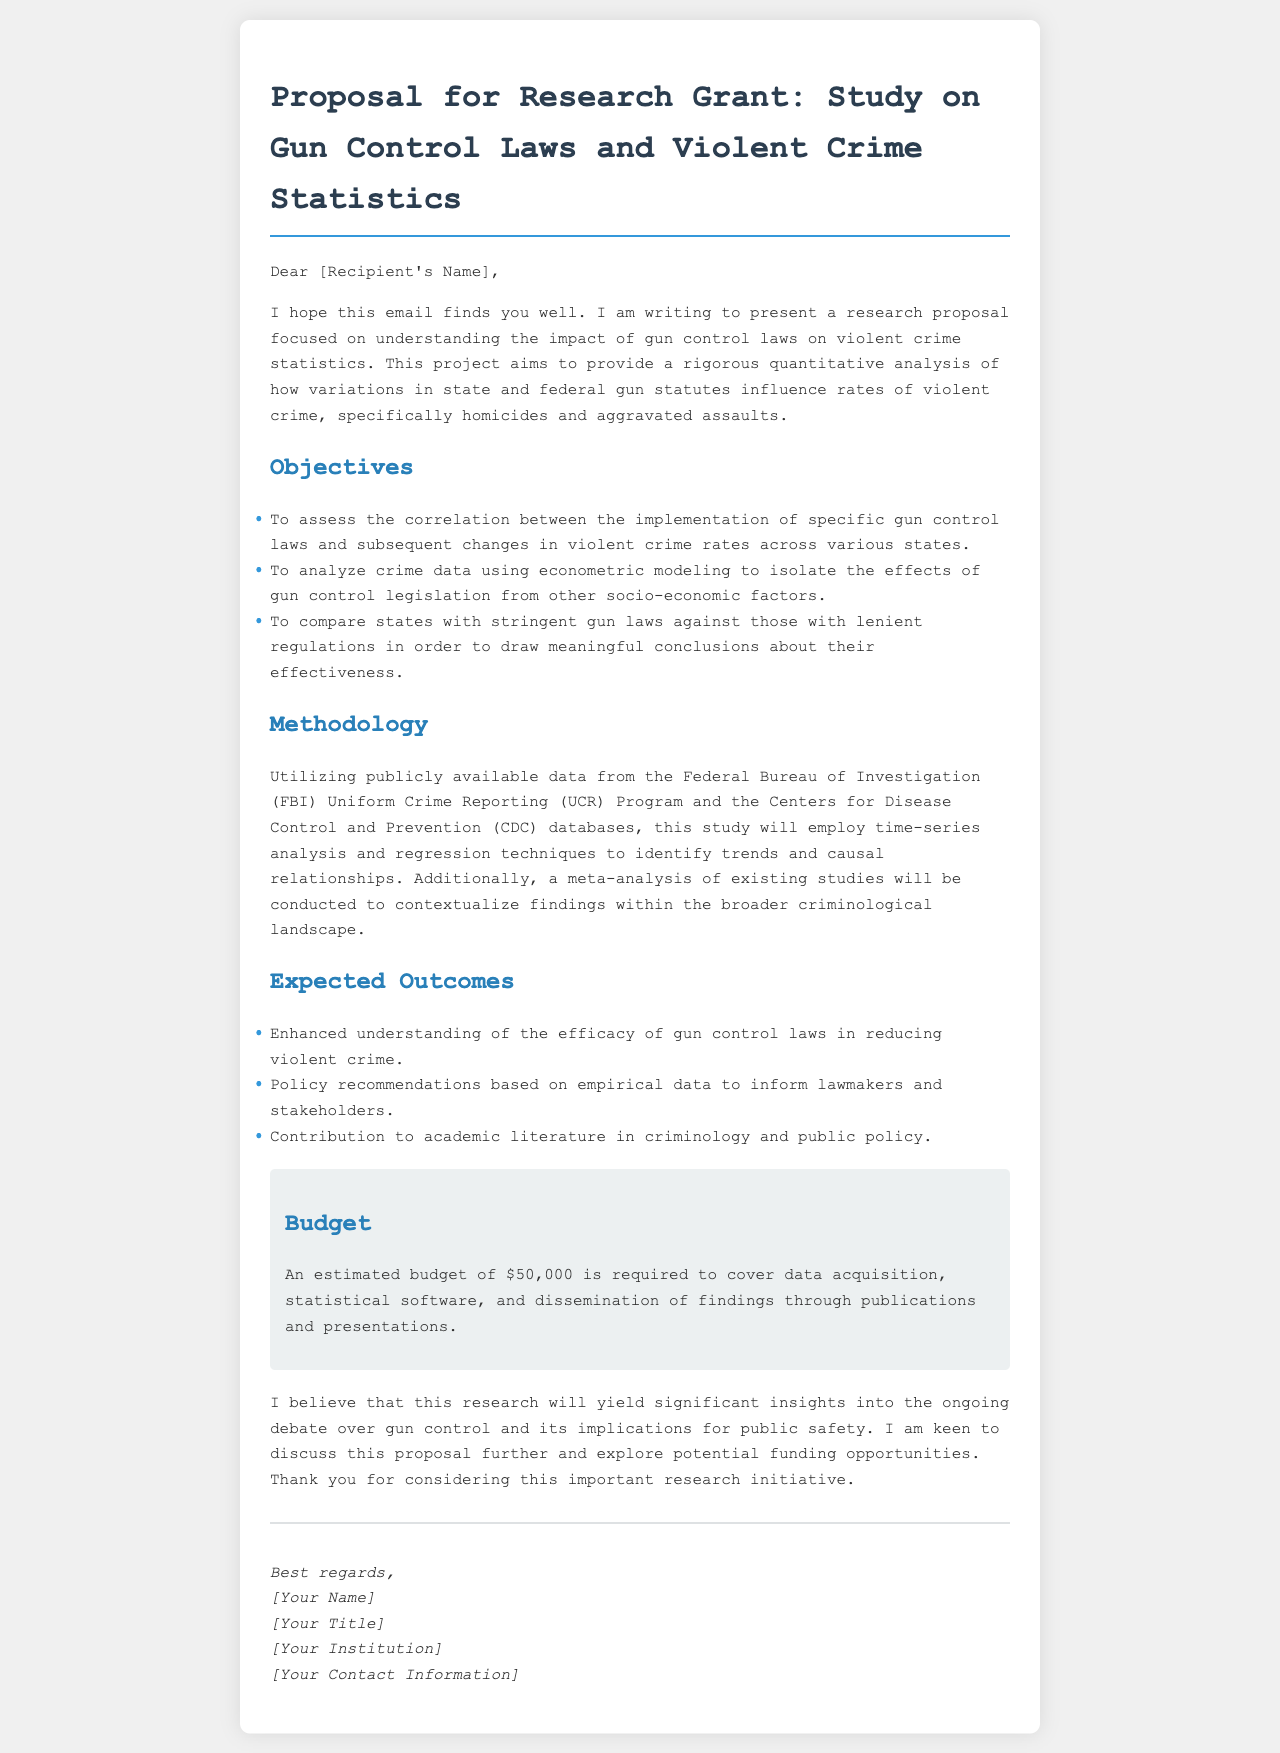What is the title of the proposal? The title of the proposal is specific to the research topic and is stated at the beginning of the document.
Answer: Proposal for Research Grant: Study on Gun Control Laws and Violent Crime Statistics What is the estimated budget required for the project? The document explicitly states the estimated amount needed for the research.
Answer: $50,000 Who is the intended recipient of the email? The recipient is referred to generically in the salutation of the email, indicating that it is directed to a specific person.
Answer: [Recipient's Name] What are the primary objectives of the research? The objectives outline the key goals of the research proposal, which can be summarized from the list provided.
Answer: Assess correlation, analyze crime data, compare states What methods will be used to analyze the data? The methodology section describes the techniques planned for analyzing crime data, detailing the type of analysis.
Answer: Time-series analysis and regression techniques What type of data will be utilized for the study? The document mentions specific sources from where the data will be collected.
Answer: FBI Uniform Crime Reporting and CDC databases What is the expected contribution of the research? The document lists several anticipated contributions of the study, highlighting its significance in various fields.
Answer: Enhanced understanding of gun control efficacy How will the findings be disseminated? The proposal mentions how the results will be shared with the community and stakeholders, emphasizing the importance of communication.
Answer: Publications and presentations Who authored the proposal? The signature section of the document provides the name and title of the person responsible for the proposal.
Answer: [Your Name] 